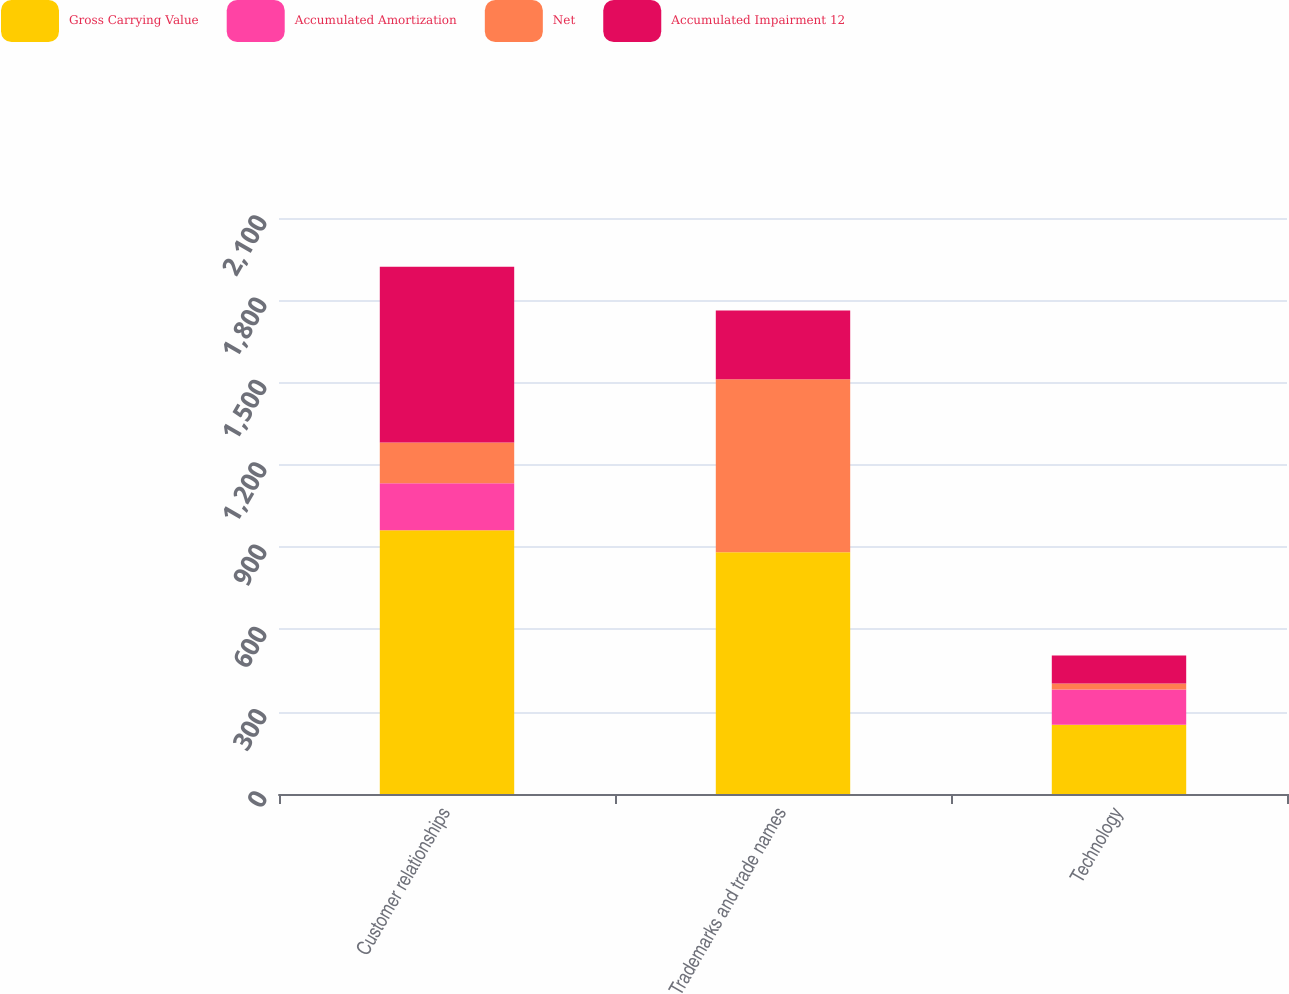Convert chart to OTSL. <chart><loc_0><loc_0><loc_500><loc_500><stacked_bar_chart><ecel><fcel>Customer relationships<fcel>Trademarks and trade names<fcel>Technology<nl><fcel>Gross Carrying Value<fcel>961.3<fcel>881.5<fcel>252.6<nl><fcel>Accumulated Amortization<fcel>171.2<fcel>0.1<fcel>128<nl><fcel>Net<fcel>148.9<fcel>630.2<fcel>22.2<nl><fcel>Accumulated Impairment 12<fcel>641.2<fcel>251.2<fcel>102.4<nl></chart> 